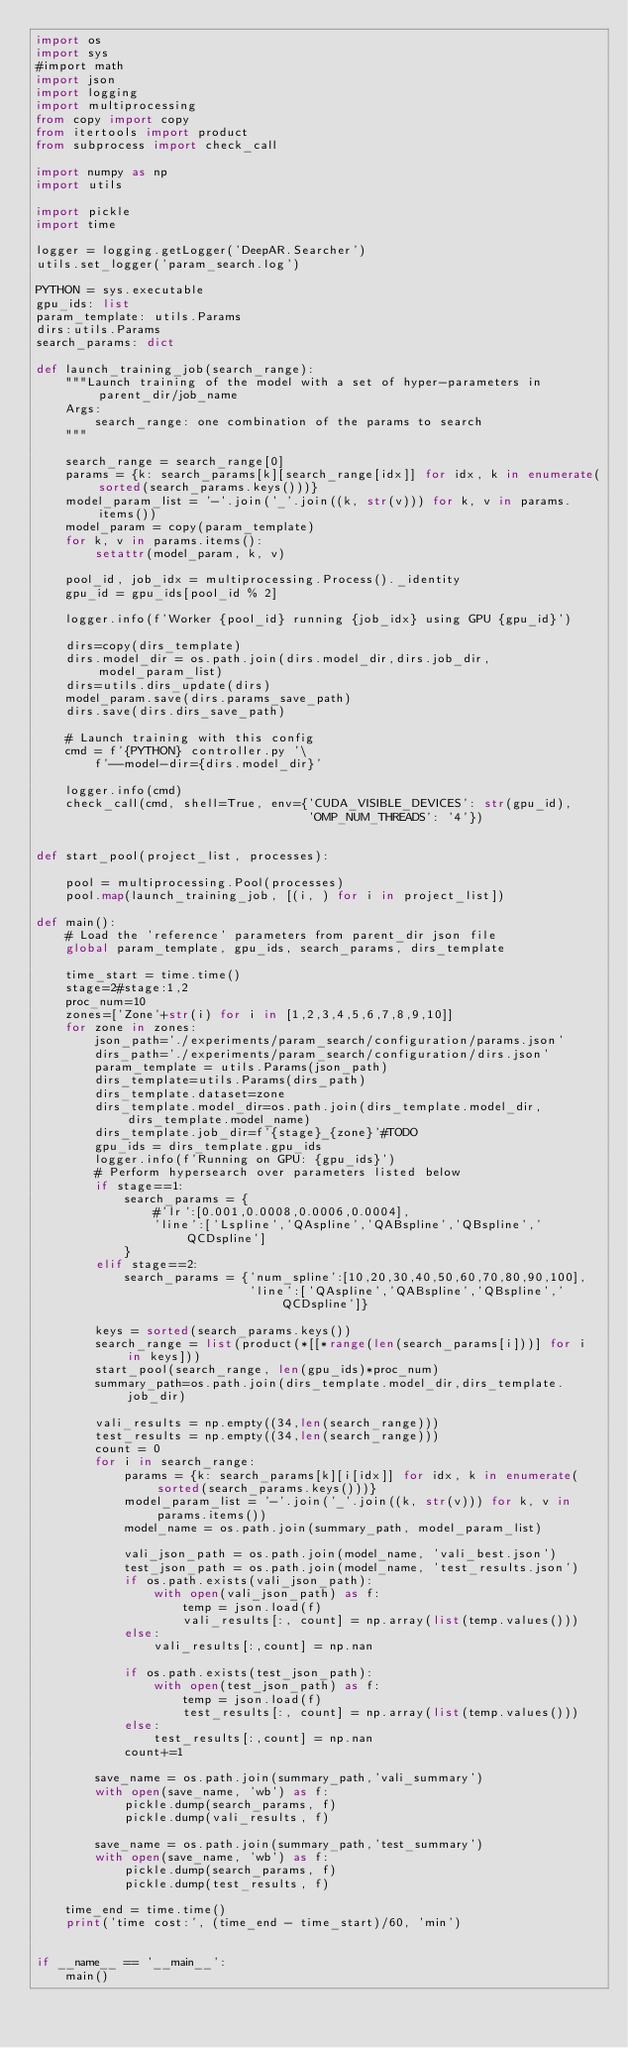Convert code to text. <code><loc_0><loc_0><loc_500><loc_500><_Python_>import os
import sys
#import math
import json
import logging
import multiprocessing
from copy import copy
from itertools import product
from subprocess import check_call

import numpy as np
import utils

import pickle
import time

logger = logging.getLogger('DeepAR.Searcher')
utils.set_logger('param_search.log')

PYTHON = sys.executable
gpu_ids: list
param_template: utils.Params
dirs:utils.Params
search_params: dict

def launch_training_job(search_range):
    """Launch training of the model with a set of hyper-parameters in parent_dir/job_name
    Args:
        search_range: one combination of the params to search
    """

    search_range = search_range[0]
    params = {k: search_params[k][search_range[idx]] for idx, k in enumerate(sorted(search_params.keys()))}
    model_param_list = '-'.join('_'.join((k, str(v))) for k, v in params.items())
    model_param = copy(param_template)
    for k, v in params.items():
        setattr(model_param, k, v)

    pool_id, job_idx = multiprocessing.Process()._identity
    gpu_id = gpu_ids[pool_id % 2]

    logger.info(f'Worker {pool_id} running {job_idx} using GPU {gpu_id}')

    dirs=copy(dirs_template)
    dirs.model_dir = os.path.join(dirs.model_dir,dirs.job_dir,model_param_list)
    dirs=utils.dirs_update(dirs)
    model_param.save(dirs.params_save_path)
    dirs.save(dirs.dirs_save_path)

    # Launch training with this config
    cmd = f'{PYTHON} controller.py '\
        f'--model-dir={dirs.model_dir}'

    logger.info(cmd)
    check_call(cmd, shell=True, env={'CUDA_VISIBLE_DEVICES': str(gpu_id),
                                     'OMP_NUM_THREADS': '4'})


def start_pool(project_list, processes):

    pool = multiprocessing.Pool(processes)
    pool.map(launch_training_job, [(i, ) for i in project_list])

def main():
    # Load the 'reference' parameters from parent_dir json file
    global param_template, gpu_ids, search_params, dirs_template

    time_start = time.time()
    stage=2#stage:1,2
    proc_num=10
    zones=['Zone'+str(i) for i in [1,2,3,4,5,6,7,8,9,10]]
    for zone in zones:
        json_path='./experiments/param_search/configuration/params.json'
        dirs_path='./experiments/param_search/configuration/dirs.json'
        param_template = utils.Params(json_path)
        dirs_template=utils.Params(dirs_path)
        dirs_template.dataset=zone
        dirs_template.model_dir=os.path.join(dirs_template.model_dir,dirs_template.model_name)
        dirs_template.job_dir=f'{stage}_{zone}'#TODO
        gpu_ids = dirs_template.gpu_ids
        logger.info(f'Running on GPU: {gpu_ids}')
        # Perform hypersearch over parameters listed below
        if stage==1:
            search_params = {
                #'lr':[0.001,0.0008,0.0006,0.0004],
                'line':['Lspline','QAspline','QABspline','QBspline','QCDspline']
            }
        elif stage==2:
            search_params = {'num_spline':[10,20,30,40,50,60,70,80,90,100],
                             'line':['QAspline','QABspline','QBspline','QCDspline']}

        keys = sorted(search_params.keys())
        search_range = list(product(*[[*range(len(search_params[i]))] for i in keys]))
        start_pool(search_range, len(gpu_ids)*proc_num)
        summary_path=os.path.join(dirs_template.model_dir,dirs_template.job_dir)

        vali_results = np.empty((34,len(search_range)))
        test_results = np.empty((34,len(search_range)))
        count = 0
        for i in search_range:
            params = {k: search_params[k][i[idx]] for idx, k in enumerate(sorted(search_params.keys()))}
            model_param_list = '-'.join('_'.join((k, str(v))) for k, v in params.items())
            model_name = os.path.join(summary_path, model_param_list)

            vali_json_path = os.path.join(model_name, 'vali_best.json')
            test_json_path = os.path.join(model_name, 'test_results.json')
            if os.path.exists(vali_json_path):
                with open(vali_json_path) as f:
                    temp = json.load(f)
                    vali_results[:, count] = np.array(list(temp.values()))
            else:
                vali_results[:,count] = np.nan

            if os.path.exists(test_json_path):
                with open(test_json_path) as f:
                    temp = json.load(f)
                    test_results[:, count] = np.array(list(temp.values()))
            else:
                test_results[:,count] = np.nan
            count+=1

        save_name = os.path.join(summary_path,'vali_summary')
        with open(save_name, 'wb') as f:
            pickle.dump(search_params, f)
            pickle.dump(vali_results, f)

        save_name = os.path.join(summary_path,'test_summary')
        with open(save_name, 'wb') as f:
            pickle.dump(search_params, f)
            pickle.dump(test_results, f)

    time_end = time.time()
    print('time cost:', (time_end - time_start)/60, 'min')


if __name__ == '__main__':
    main()
</code> 